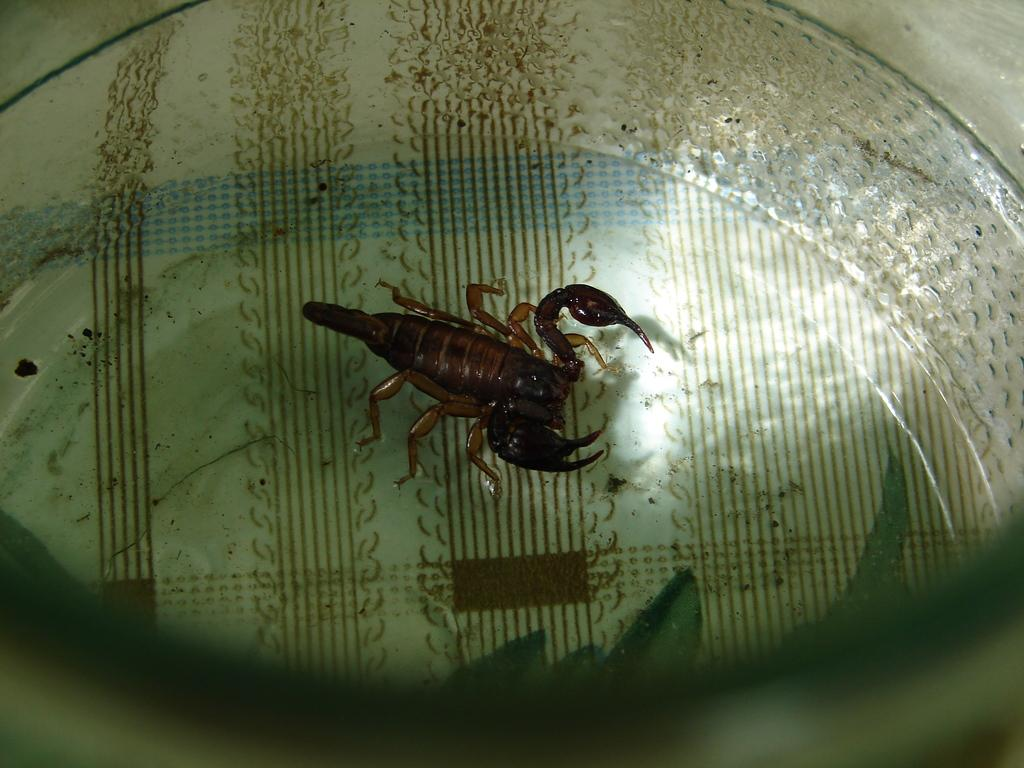What is the main subject on the plate in the image? There is a Scorpio on a plate in the image. How many trees are visible in the image? There are no trees visible in the image; it features a Scorpio on a plate. What type of root can be seen growing from the Scorpio in the image? There is no root growing from the Scorpio in the image, as it is a zodiac sign and not a living organism. 